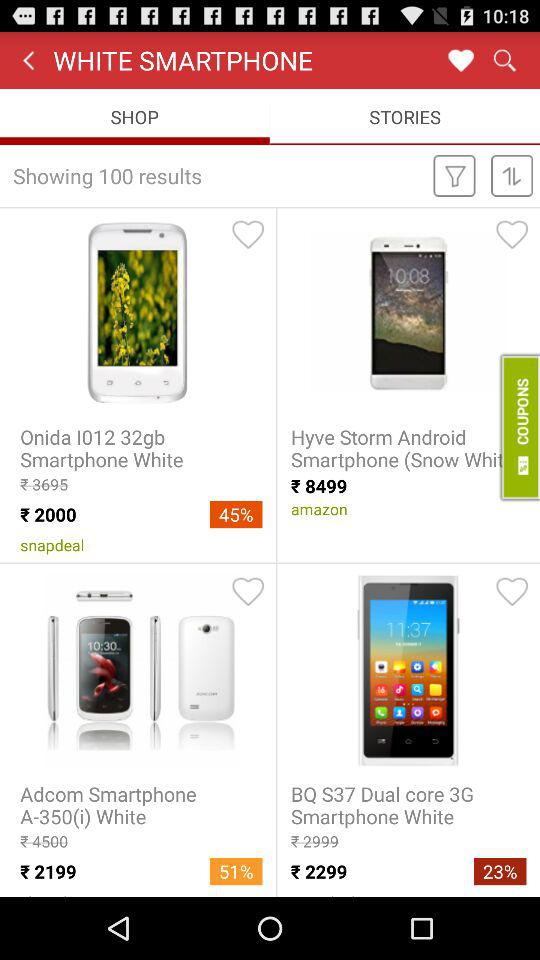What is the discount percentage applicable on "Adcom Smartphone A-350"? The discount percentage applicable on "Adcom Smartphone A-350" is 51. 